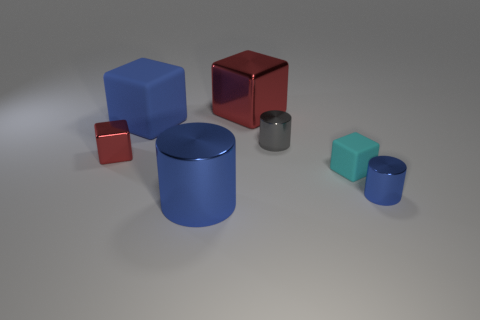Subtract all large blue metallic cylinders. How many cylinders are left? 2 Subtract all blue blocks. How many blocks are left? 3 Subtract all yellow cylinders. How many red blocks are left? 2 Subtract 1 cubes. How many cubes are left? 3 Add 1 large gray shiny cylinders. How many objects exist? 8 Subtract all cylinders. How many objects are left? 4 Subtract all red cylinders. Subtract all red spheres. How many cylinders are left? 3 Subtract all tiny red metallic blocks. Subtract all small gray cylinders. How many objects are left? 5 Add 7 large blue metal cylinders. How many large blue metal cylinders are left? 8 Add 3 cubes. How many cubes exist? 7 